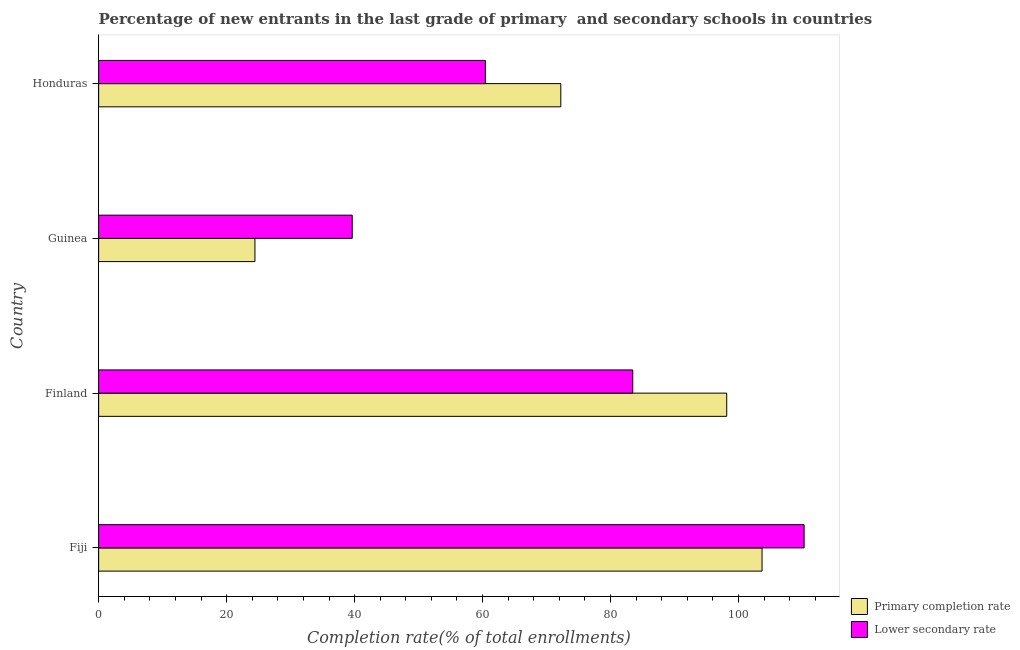How many different coloured bars are there?
Offer a terse response. 2. How many groups of bars are there?
Offer a terse response. 4. Are the number of bars per tick equal to the number of legend labels?
Keep it short and to the point. Yes. How many bars are there on the 4th tick from the top?
Ensure brevity in your answer.  2. What is the label of the 1st group of bars from the top?
Your answer should be compact. Honduras. What is the completion rate in primary schools in Finland?
Make the answer very short. 98.15. Across all countries, what is the maximum completion rate in primary schools?
Your response must be concise. 103.67. Across all countries, what is the minimum completion rate in secondary schools?
Provide a short and direct response. 39.63. In which country was the completion rate in primary schools maximum?
Keep it short and to the point. Fiji. In which country was the completion rate in primary schools minimum?
Your response must be concise. Guinea. What is the total completion rate in secondary schools in the graph?
Offer a terse response. 293.78. What is the difference between the completion rate in secondary schools in Finland and that in Honduras?
Keep it short and to the point. 23.03. What is the difference between the completion rate in secondary schools in Finland and the completion rate in primary schools in Guinea?
Make the answer very short. 59.04. What is the average completion rate in primary schools per country?
Your answer should be compact. 74.62. What is the difference between the completion rate in secondary schools and completion rate in primary schools in Fiji?
Offer a terse response. 6.58. In how many countries, is the completion rate in secondary schools greater than 72 %?
Ensure brevity in your answer.  2. What is the ratio of the completion rate in primary schools in Fiji to that in Guinea?
Keep it short and to the point. 4.24. Is the completion rate in primary schools in Finland less than that in Honduras?
Provide a succinct answer. No. Is the difference between the completion rate in secondary schools in Finland and Guinea greater than the difference between the completion rate in primary schools in Finland and Guinea?
Your answer should be compact. No. What is the difference between the highest and the second highest completion rate in secondary schools?
Ensure brevity in your answer.  26.78. What is the difference between the highest and the lowest completion rate in secondary schools?
Offer a terse response. 70.62. Is the sum of the completion rate in primary schools in Fiji and Guinea greater than the maximum completion rate in secondary schools across all countries?
Keep it short and to the point. Yes. What does the 1st bar from the top in Finland represents?
Offer a terse response. Lower secondary rate. What does the 2nd bar from the bottom in Fiji represents?
Your answer should be compact. Lower secondary rate. Are all the bars in the graph horizontal?
Your answer should be compact. Yes. How many countries are there in the graph?
Keep it short and to the point. 4. What is the difference between two consecutive major ticks on the X-axis?
Make the answer very short. 20. Does the graph contain any zero values?
Provide a succinct answer. No. Does the graph contain grids?
Keep it short and to the point. No. Where does the legend appear in the graph?
Your answer should be compact. Bottom right. How many legend labels are there?
Your answer should be compact. 2. How are the legend labels stacked?
Give a very brief answer. Vertical. What is the title of the graph?
Keep it short and to the point. Percentage of new entrants in the last grade of primary  and secondary schools in countries. What is the label or title of the X-axis?
Offer a terse response. Completion rate(% of total enrollments). What is the label or title of the Y-axis?
Your answer should be compact. Country. What is the Completion rate(% of total enrollments) in Primary completion rate in Fiji?
Make the answer very short. 103.67. What is the Completion rate(% of total enrollments) in Lower secondary rate in Fiji?
Ensure brevity in your answer.  110.25. What is the Completion rate(% of total enrollments) of Primary completion rate in Finland?
Give a very brief answer. 98.15. What is the Completion rate(% of total enrollments) in Lower secondary rate in Finland?
Your answer should be very brief. 83.47. What is the Completion rate(% of total enrollments) in Primary completion rate in Guinea?
Ensure brevity in your answer.  24.43. What is the Completion rate(% of total enrollments) in Lower secondary rate in Guinea?
Offer a terse response. 39.63. What is the Completion rate(% of total enrollments) in Primary completion rate in Honduras?
Keep it short and to the point. 72.23. What is the Completion rate(% of total enrollments) in Lower secondary rate in Honduras?
Ensure brevity in your answer.  60.43. Across all countries, what is the maximum Completion rate(% of total enrollments) in Primary completion rate?
Offer a terse response. 103.67. Across all countries, what is the maximum Completion rate(% of total enrollments) of Lower secondary rate?
Ensure brevity in your answer.  110.25. Across all countries, what is the minimum Completion rate(% of total enrollments) of Primary completion rate?
Provide a short and direct response. 24.43. Across all countries, what is the minimum Completion rate(% of total enrollments) in Lower secondary rate?
Your response must be concise. 39.63. What is the total Completion rate(% of total enrollments) in Primary completion rate in the graph?
Provide a succinct answer. 298.48. What is the total Completion rate(% of total enrollments) in Lower secondary rate in the graph?
Your answer should be compact. 293.78. What is the difference between the Completion rate(% of total enrollments) of Primary completion rate in Fiji and that in Finland?
Your response must be concise. 5.52. What is the difference between the Completion rate(% of total enrollments) in Lower secondary rate in Fiji and that in Finland?
Provide a short and direct response. 26.78. What is the difference between the Completion rate(% of total enrollments) in Primary completion rate in Fiji and that in Guinea?
Your response must be concise. 79.25. What is the difference between the Completion rate(% of total enrollments) in Lower secondary rate in Fiji and that in Guinea?
Provide a succinct answer. 70.62. What is the difference between the Completion rate(% of total enrollments) of Primary completion rate in Fiji and that in Honduras?
Your answer should be compact. 31.45. What is the difference between the Completion rate(% of total enrollments) in Lower secondary rate in Fiji and that in Honduras?
Provide a succinct answer. 49.82. What is the difference between the Completion rate(% of total enrollments) in Primary completion rate in Finland and that in Guinea?
Your answer should be very brief. 73.73. What is the difference between the Completion rate(% of total enrollments) in Lower secondary rate in Finland and that in Guinea?
Your answer should be compact. 43.84. What is the difference between the Completion rate(% of total enrollments) of Primary completion rate in Finland and that in Honduras?
Offer a terse response. 25.93. What is the difference between the Completion rate(% of total enrollments) of Lower secondary rate in Finland and that in Honduras?
Keep it short and to the point. 23.03. What is the difference between the Completion rate(% of total enrollments) of Primary completion rate in Guinea and that in Honduras?
Make the answer very short. -47.8. What is the difference between the Completion rate(% of total enrollments) in Lower secondary rate in Guinea and that in Honduras?
Provide a succinct answer. -20.8. What is the difference between the Completion rate(% of total enrollments) in Primary completion rate in Fiji and the Completion rate(% of total enrollments) in Lower secondary rate in Finland?
Your response must be concise. 20.21. What is the difference between the Completion rate(% of total enrollments) in Primary completion rate in Fiji and the Completion rate(% of total enrollments) in Lower secondary rate in Guinea?
Give a very brief answer. 64.04. What is the difference between the Completion rate(% of total enrollments) of Primary completion rate in Fiji and the Completion rate(% of total enrollments) of Lower secondary rate in Honduras?
Make the answer very short. 43.24. What is the difference between the Completion rate(% of total enrollments) in Primary completion rate in Finland and the Completion rate(% of total enrollments) in Lower secondary rate in Guinea?
Your answer should be compact. 58.52. What is the difference between the Completion rate(% of total enrollments) of Primary completion rate in Finland and the Completion rate(% of total enrollments) of Lower secondary rate in Honduras?
Offer a terse response. 37.72. What is the difference between the Completion rate(% of total enrollments) of Primary completion rate in Guinea and the Completion rate(% of total enrollments) of Lower secondary rate in Honduras?
Your answer should be very brief. -36.01. What is the average Completion rate(% of total enrollments) in Primary completion rate per country?
Your answer should be very brief. 74.62. What is the average Completion rate(% of total enrollments) of Lower secondary rate per country?
Make the answer very short. 73.45. What is the difference between the Completion rate(% of total enrollments) of Primary completion rate and Completion rate(% of total enrollments) of Lower secondary rate in Fiji?
Your response must be concise. -6.58. What is the difference between the Completion rate(% of total enrollments) in Primary completion rate and Completion rate(% of total enrollments) in Lower secondary rate in Finland?
Keep it short and to the point. 14.69. What is the difference between the Completion rate(% of total enrollments) of Primary completion rate and Completion rate(% of total enrollments) of Lower secondary rate in Guinea?
Make the answer very short. -15.2. What is the difference between the Completion rate(% of total enrollments) of Primary completion rate and Completion rate(% of total enrollments) of Lower secondary rate in Honduras?
Offer a terse response. 11.79. What is the ratio of the Completion rate(% of total enrollments) in Primary completion rate in Fiji to that in Finland?
Provide a succinct answer. 1.06. What is the ratio of the Completion rate(% of total enrollments) in Lower secondary rate in Fiji to that in Finland?
Keep it short and to the point. 1.32. What is the ratio of the Completion rate(% of total enrollments) of Primary completion rate in Fiji to that in Guinea?
Offer a terse response. 4.24. What is the ratio of the Completion rate(% of total enrollments) in Lower secondary rate in Fiji to that in Guinea?
Keep it short and to the point. 2.78. What is the ratio of the Completion rate(% of total enrollments) of Primary completion rate in Fiji to that in Honduras?
Offer a terse response. 1.44. What is the ratio of the Completion rate(% of total enrollments) in Lower secondary rate in Fiji to that in Honduras?
Provide a succinct answer. 1.82. What is the ratio of the Completion rate(% of total enrollments) of Primary completion rate in Finland to that in Guinea?
Keep it short and to the point. 4.02. What is the ratio of the Completion rate(% of total enrollments) of Lower secondary rate in Finland to that in Guinea?
Ensure brevity in your answer.  2.11. What is the ratio of the Completion rate(% of total enrollments) of Primary completion rate in Finland to that in Honduras?
Offer a very short reply. 1.36. What is the ratio of the Completion rate(% of total enrollments) of Lower secondary rate in Finland to that in Honduras?
Make the answer very short. 1.38. What is the ratio of the Completion rate(% of total enrollments) in Primary completion rate in Guinea to that in Honduras?
Offer a terse response. 0.34. What is the ratio of the Completion rate(% of total enrollments) in Lower secondary rate in Guinea to that in Honduras?
Keep it short and to the point. 0.66. What is the difference between the highest and the second highest Completion rate(% of total enrollments) in Primary completion rate?
Provide a short and direct response. 5.52. What is the difference between the highest and the second highest Completion rate(% of total enrollments) of Lower secondary rate?
Your answer should be very brief. 26.78. What is the difference between the highest and the lowest Completion rate(% of total enrollments) of Primary completion rate?
Make the answer very short. 79.25. What is the difference between the highest and the lowest Completion rate(% of total enrollments) of Lower secondary rate?
Provide a short and direct response. 70.62. 